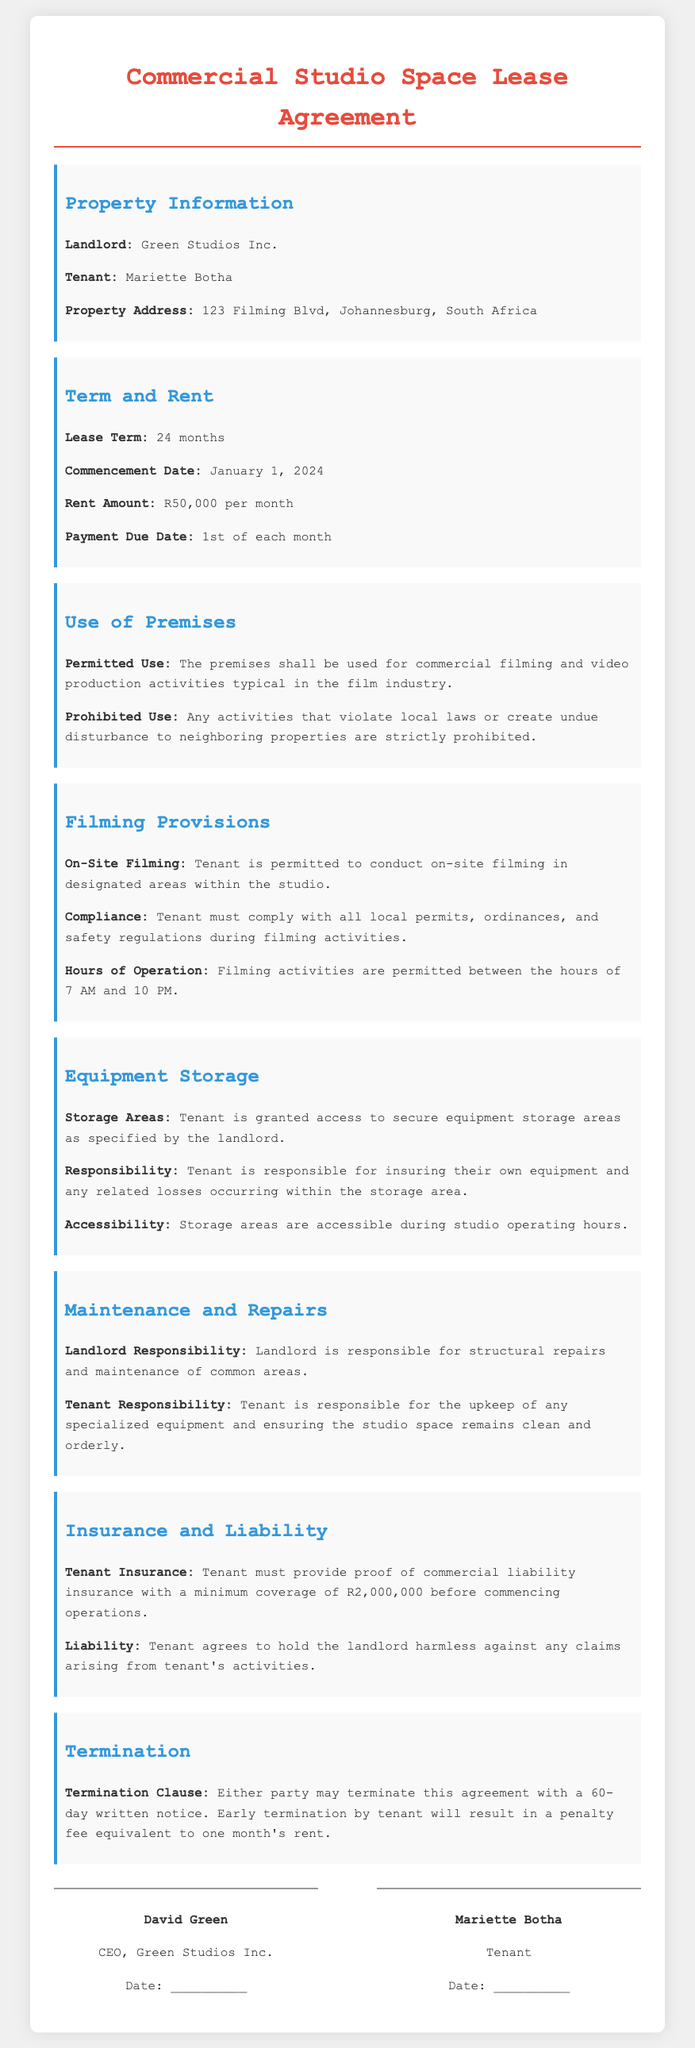What is the name of the landlord? The landlord's name is specified in the property information section.
Answer: Green Studios Inc What is the monthly rent amount? The rent amount is clearly stated in the term and rent section of the document.
Answer: R50,000 What is the lease term duration? The lease term is mentioned in the term and rent section of the document.
Answer: 24 months When is the payment due? The payment due date is indicated in the term and rent section of the document.
Answer: 1st of each month What is the minimum insurance coverage required? The insurance requirement is detailed in the insurance and liability section.
Answer: R2,000,000 What are the permitted hours for filming? The allowed filming hours are listed under the filming provisions section.
Answer: 7 AM to 10 PM Who is responsible for storage area maintenance? Responsibility for maintenance is addressed in the maintenance and repairs section, specifying tenant obligations.
Answer: Tenant What is the penalty for early termination by the tenant? The consequences of early termination are specified in the termination section.
Answer: One month's rent What must the tenant provide before commencing operations? The document specifies a requirement that must be fulfilled by the tenant prior to operations.
Answer: Proof of commercial liability insurance 